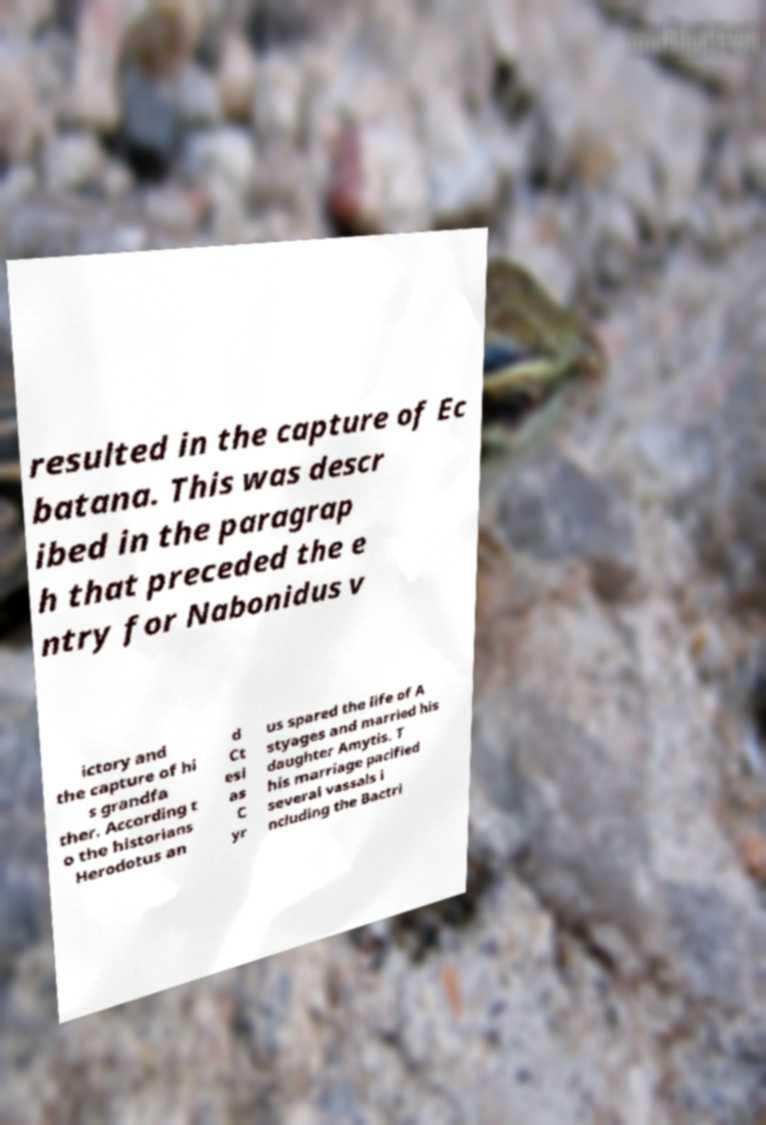I need the written content from this picture converted into text. Can you do that? resulted in the capture of Ec batana. This was descr ibed in the paragrap h that preceded the e ntry for Nabonidus v ictory and the capture of hi s grandfa ther. According t o the historians Herodotus an d Ct esi as C yr us spared the life of A styages and married his daughter Amytis. T his marriage pacified several vassals i ncluding the Bactri 